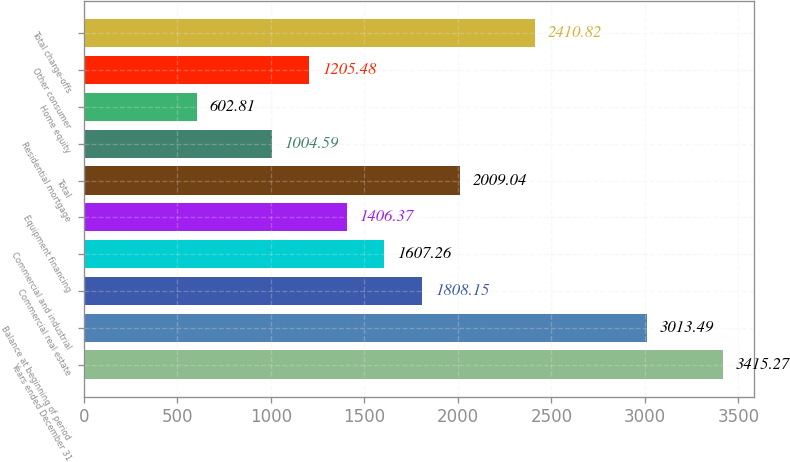<chart> <loc_0><loc_0><loc_500><loc_500><bar_chart><fcel>Years ended December 31<fcel>Balance at beginning of period<fcel>Commercial real estate<fcel>Commercial and industrial<fcel>Equipment financing<fcel>Total<fcel>Residential mortgage<fcel>Home equity<fcel>Other consumer<fcel>Total charge-offs<nl><fcel>3415.27<fcel>3013.49<fcel>1808.15<fcel>1607.26<fcel>1406.37<fcel>2009.04<fcel>1004.59<fcel>602.81<fcel>1205.48<fcel>2410.82<nl></chart> 